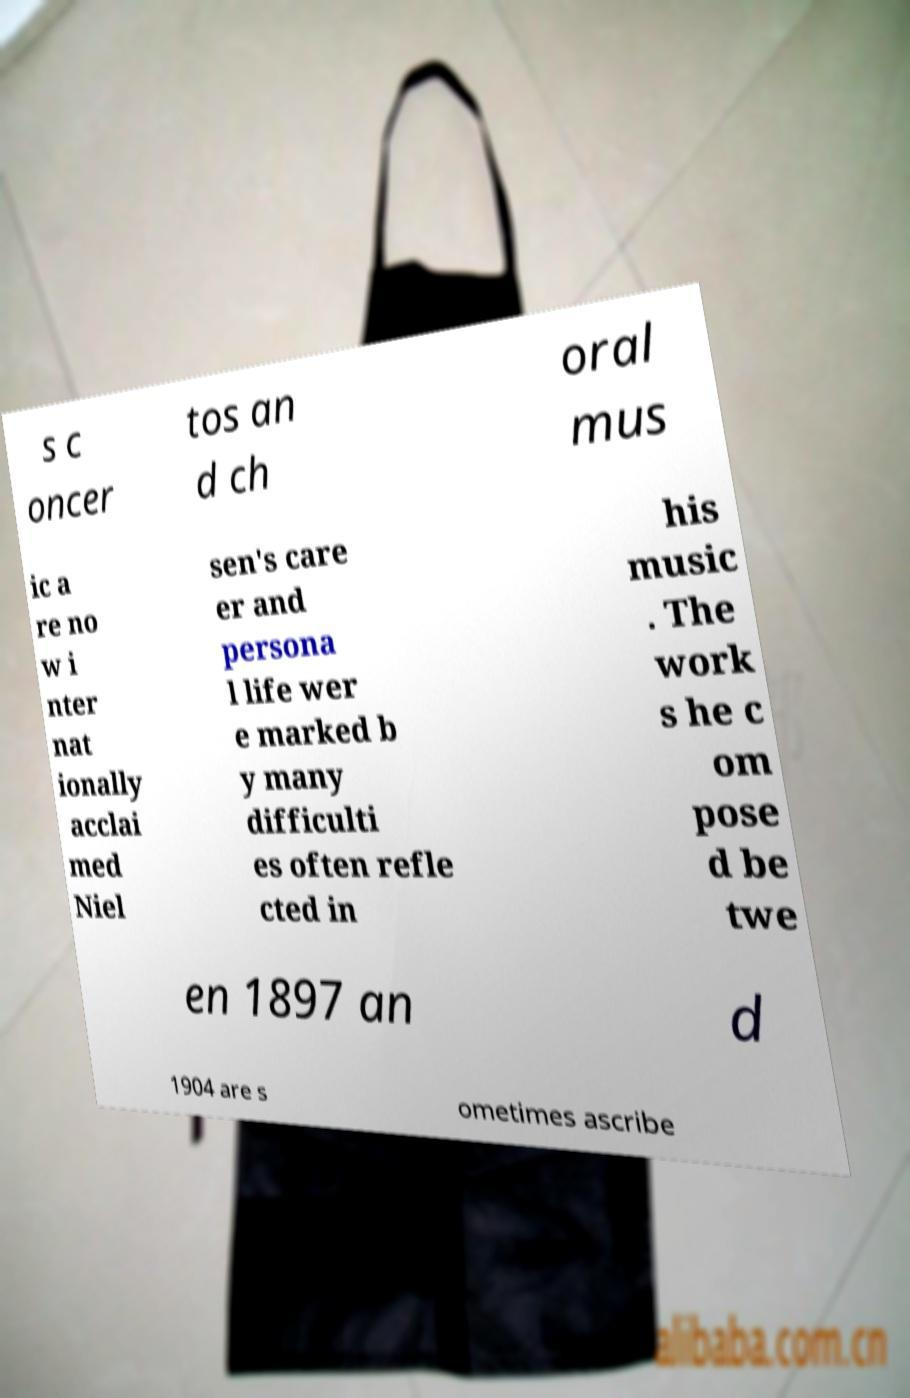Please identify and transcribe the text found in this image. s c oncer tos an d ch oral mus ic a re no w i nter nat ionally acclai med Niel sen's care er and persona l life wer e marked b y many difficulti es often refle cted in his music . The work s he c om pose d be twe en 1897 an d 1904 are s ometimes ascribe 